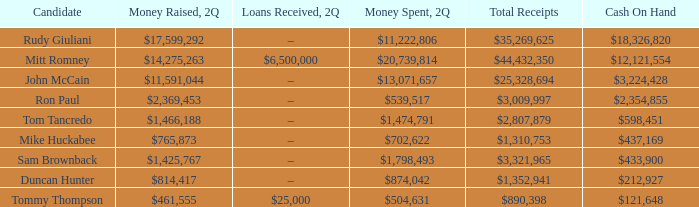Name the loans received for 2Q having total receipts of $25,328,694 –. 